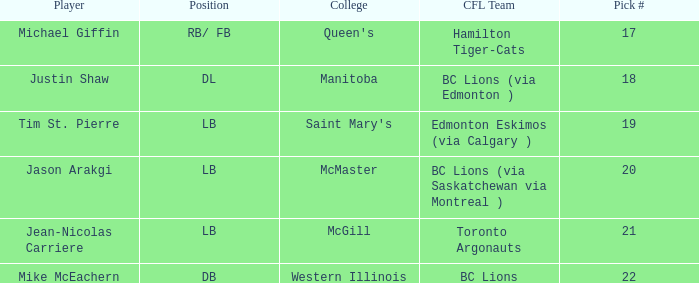How many cfl teams had pick # 21? 1.0. 